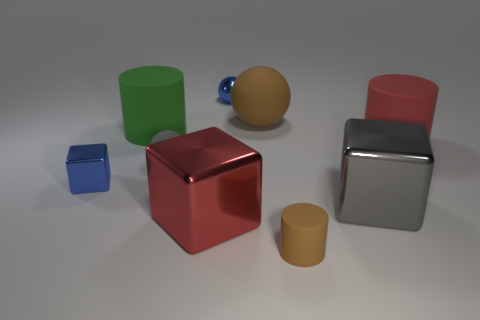Subtract all big green matte cylinders. How many cylinders are left? 2 Add 1 large gray metal blocks. How many objects exist? 10 Subtract all brown cylinders. How many cylinders are left? 2 Subtract 2 balls. How many balls are left? 1 Subtract 0 purple blocks. How many objects are left? 9 Subtract all spheres. How many objects are left? 6 Subtract all brown balls. Subtract all gray cubes. How many balls are left? 2 Subtract all blue spheres. How many brown cubes are left? 0 Subtract all small metallic balls. Subtract all large shiny things. How many objects are left? 6 Add 8 big spheres. How many big spheres are left? 9 